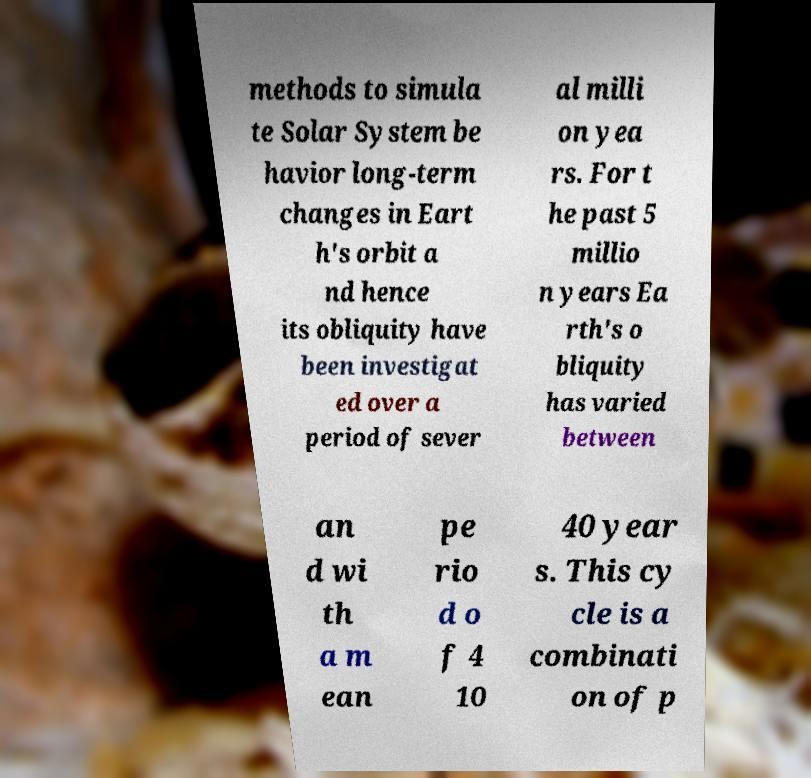Please identify and transcribe the text found in this image. methods to simula te Solar System be havior long-term changes in Eart h's orbit a nd hence its obliquity have been investigat ed over a period of sever al milli on yea rs. For t he past 5 millio n years Ea rth's o bliquity has varied between an d wi th a m ean pe rio d o f 4 10 40 year s. This cy cle is a combinati on of p 